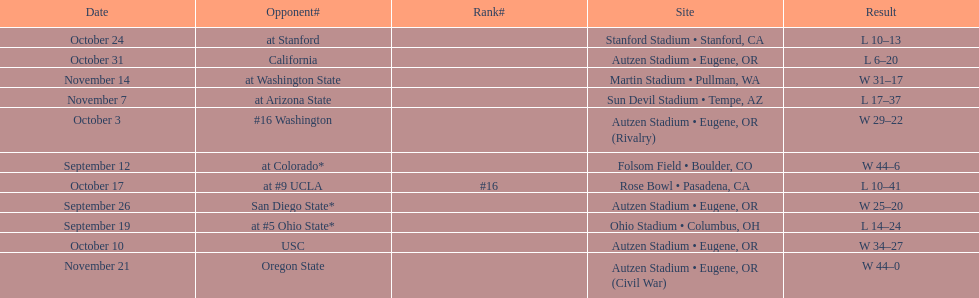What is the number of away games ? 6. 